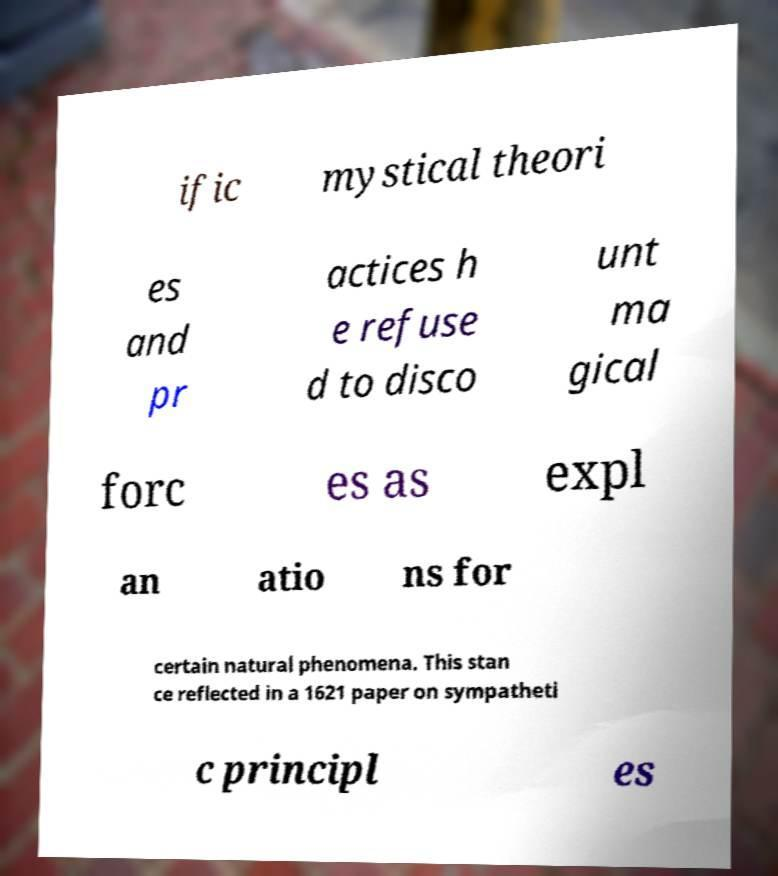Can you accurately transcribe the text from the provided image for me? ific mystical theori es and pr actices h e refuse d to disco unt ma gical forc es as expl an atio ns for certain natural phenomena. This stan ce reflected in a 1621 paper on sympatheti c principl es 